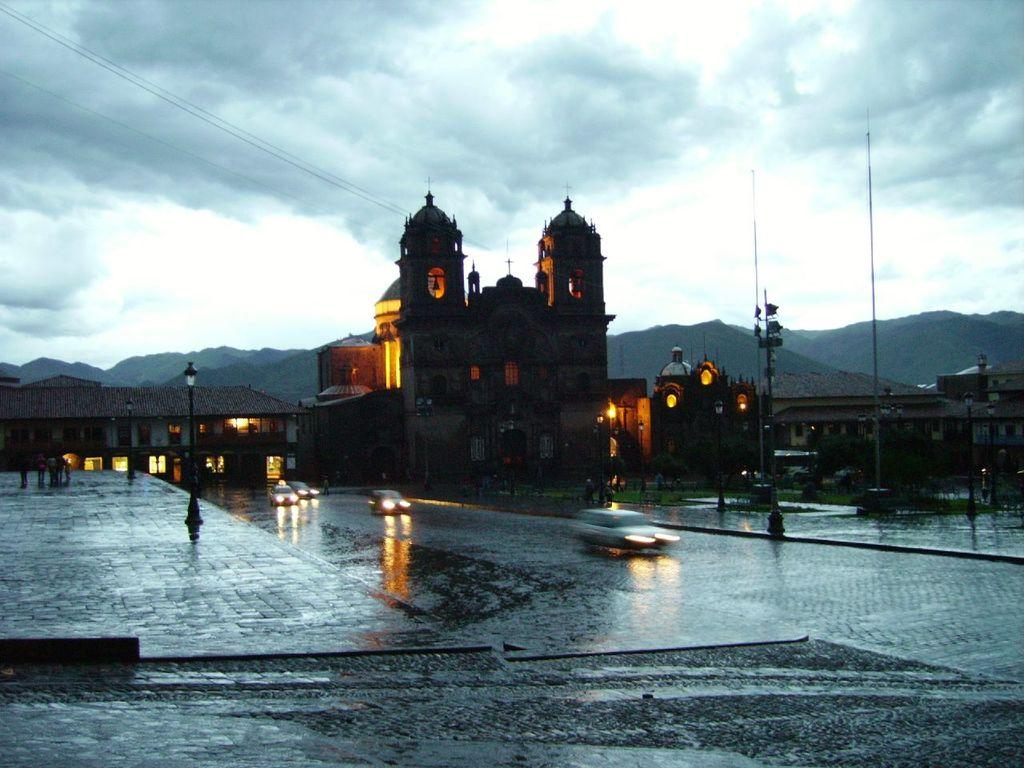What is happening on the road in the image? Vehicles are on the road in the image. What type of structures can be seen in the image? There are buildings in the image. What are the light poles used for in the image? The light poles are present for illumination purposes. Can you describe the people visible in the image? People are visible in the image, but their specific actions or characteristics are not mentioned in the provided facts. What is the condition of the sky in the image? The sky is cloudy in the image. What type of landscape feature can be seen in the distance? Hills are visible in the distance in the image. What smell can be detected from the image? There is no information about smells in the image, as it only provides visual information. What type of amusement can be found in the image? There is no mention of any amusement in the image; it only shows vehicles, buildings, light poles, people, a cloudy sky, and hills in the distance. 